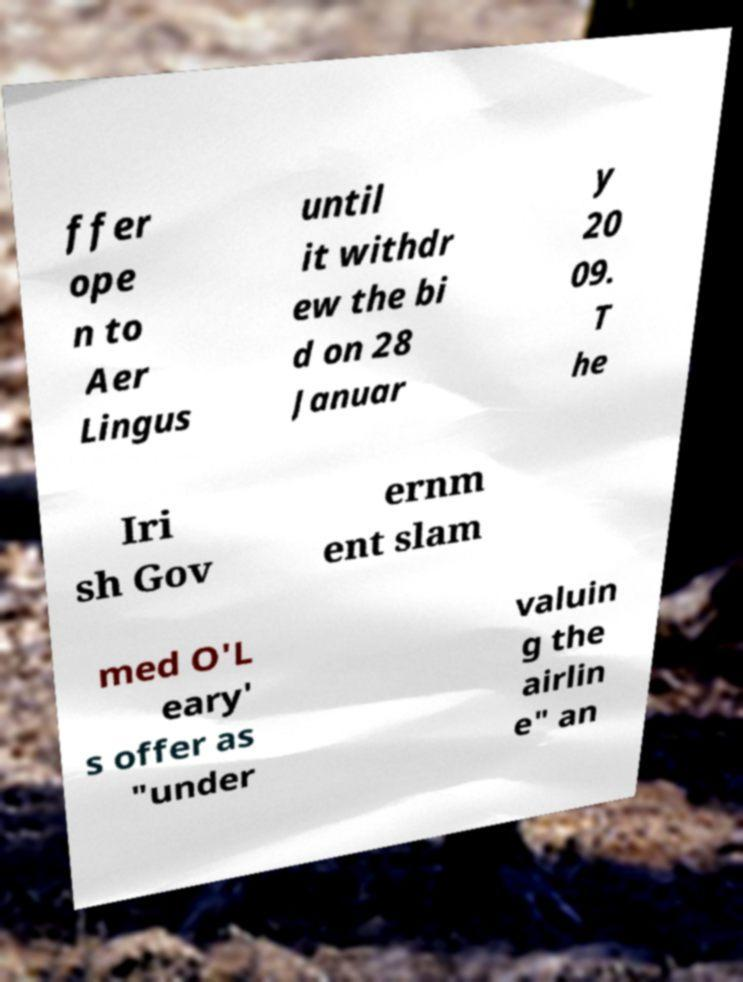There's text embedded in this image that I need extracted. Can you transcribe it verbatim? ffer ope n to Aer Lingus until it withdr ew the bi d on 28 Januar y 20 09. T he Iri sh Gov ernm ent slam med O'L eary' s offer as "under valuin g the airlin e" an 